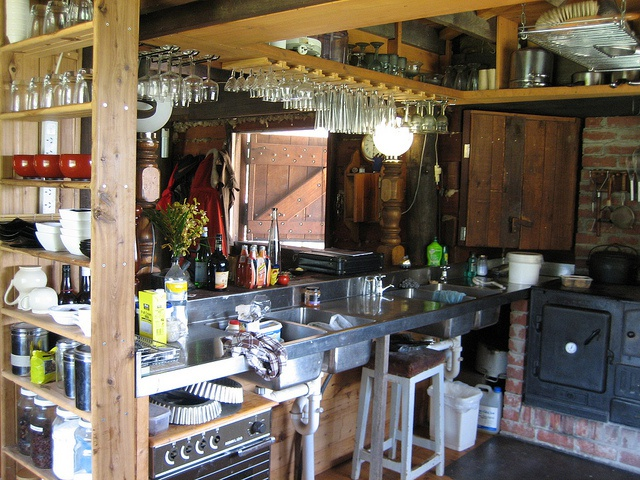Describe the objects in this image and their specific colors. I can see oven in olive, black, navy, darkblue, and gray tones, wine glass in olive, black, tan, darkgray, and gray tones, bottle in olive, black, white, gray, and purple tones, sink in olive, white, darkgray, and gray tones, and sink in olive, black, purple, and blue tones in this image. 